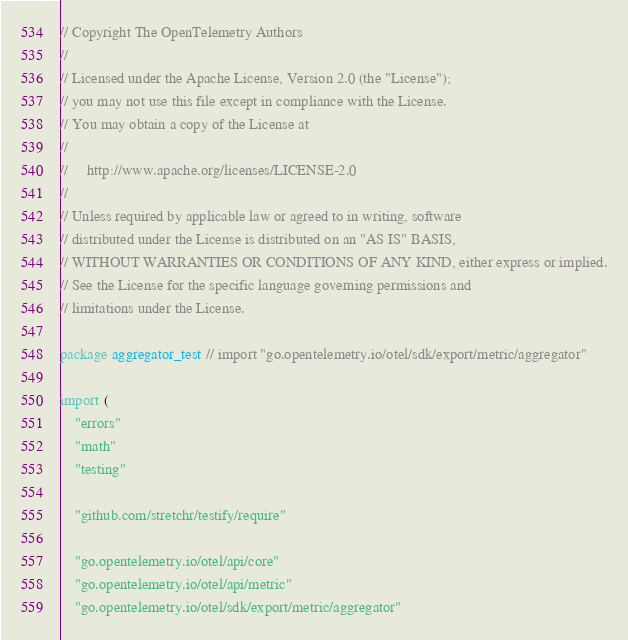Convert code to text. <code><loc_0><loc_0><loc_500><loc_500><_Go_>// Copyright The OpenTelemetry Authors
//
// Licensed under the Apache License, Version 2.0 (the "License");
// you may not use this file except in compliance with the License.
// You may obtain a copy of the License at
//
//     http://www.apache.org/licenses/LICENSE-2.0
//
// Unless required by applicable law or agreed to in writing, software
// distributed under the License is distributed on an "AS IS" BASIS,
// WITHOUT WARRANTIES OR CONDITIONS OF ANY KIND, either express or implied.
// See the License for the specific language governing permissions and
// limitations under the License.

package aggregator_test // import "go.opentelemetry.io/otel/sdk/export/metric/aggregator"

import (
	"errors"
	"math"
	"testing"

	"github.com/stretchr/testify/require"

	"go.opentelemetry.io/otel/api/core"
	"go.opentelemetry.io/otel/api/metric"
	"go.opentelemetry.io/otel/sdk/export/metric/aggregator"</code> 